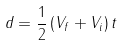Convert formula to latex. <formula><loc_0><loc_0><loc_500><loc_500>d = { \frac { 1 } { 2 } } \left ( V _ { f } + V _ { i } \right ) t</formula> 